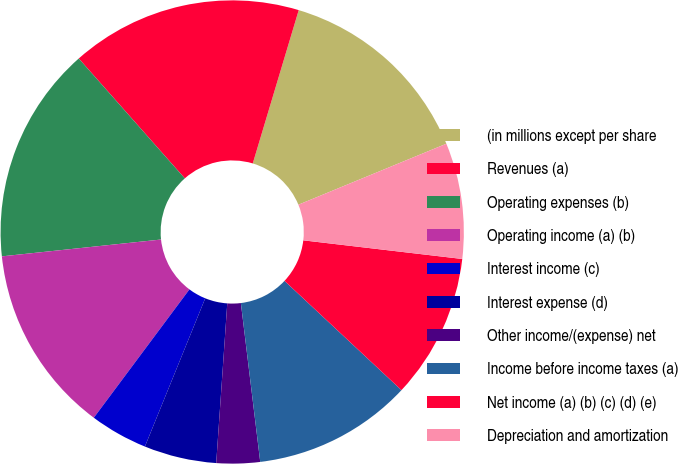Convert chart. <chart><loc_0><loc_0><loc_500><loc_500><pie_chart><fcel>(in millions except per share<fcel>Revenues (a)<fcel>Operating expenses (b)<fcel>Operating income (a) (b)<fcel>Interest income (c)<fcel>Interest expense (d)<fcel>Other income/(expense) net<fcel>Income before income taxes (a)<fcel>Net income (a) (b) (c) (d) (e)<fcel>Depreciation and amortization<nl><fcel>14.14%<fcel>16.16%<fcel>15.15%<fcel>13.13%<fcel>4.04%<fcel>5.05%<fcel>3.03%<fcel>11.11%<fcel>10.1%<fcel>8.08%<nl></chart> 